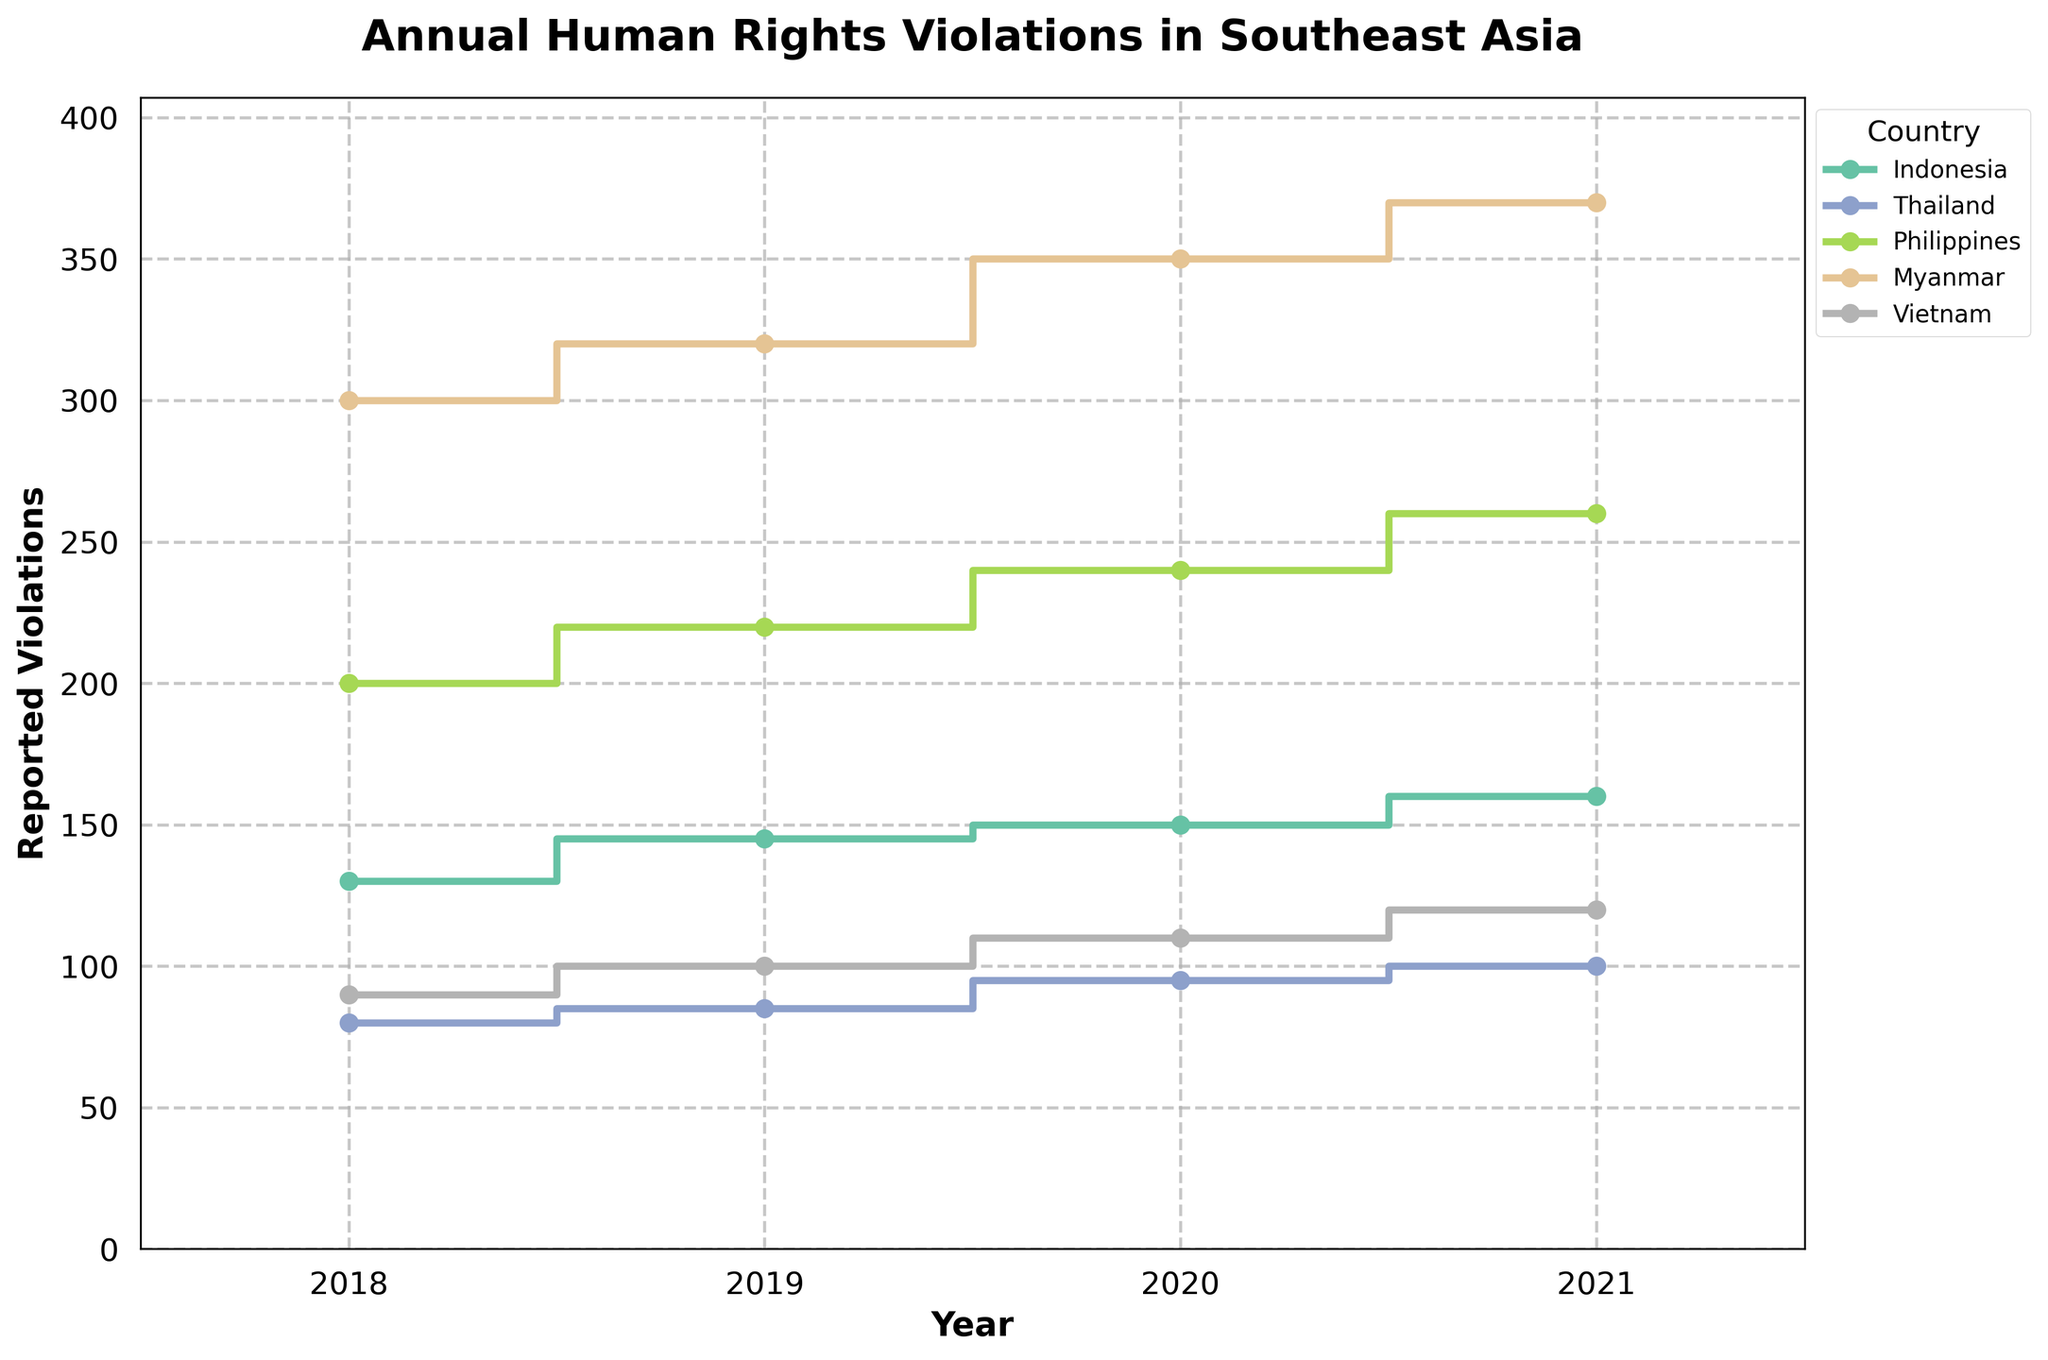What is the title of the figure? The title of the figure is typically found at the top of the chart. It describes the main topic or purpose of the figure, which in this case is "Annual Human Rights Violations in Southeast Asia".
Answer: Annual Human Rights Violations in Southeast Asia Which country had the highest number of reported violations in 2018? Looking at the step plot for the year 2018, observe which country's data point is the highest. Myanmar's data point is the highest in 2018.
Answer: Myanmar In which years did Indonesia report an increase in human rights violations? By observing the trend line for Indonesia, notice that the reported violations increased every year. Hence, the increases occurred in 2019, 2020, and 2021.
Answer: 2019, 2020, 2021 What is the difference in the number of reported violations between the Philippines and Vietnam in 2020? First, find the reported violations for both countries in 2020 from the step plot. The Philippines had 240, and Vietnam had 110. The difference is calculated as 240 - 110.
Answer: 130 How did the trend of reported violations change in Thailand from 2018 to 2021? Observing Thailand's line, it shows a consistent increase each year from 80 in 2018 to 100 in 2021. Thus, the trend is gradually increasing.
Answer: Gradually increasing Which country showed the smallest increase in reported violations from 2018 to 2021? To find this, calculate the increase for each country by subtracting reported violations in 2018 from those in 2021. The smallest increase is in Thailand: 100 - 80 = 20.
Answer: Thailand Compare the number of reported violations in Indonesia and Myanmar in 2021. Which country reported more? Look at the data points for Indonesia and Myanmar in 2021. Indonesia reported 160, and Myanmar reported 370. Myanmar reported more.
Answer: Myanmar What is the average number of reported violations for the Philippines from 2018 to 2021? Add the reported violations for the Philippines each year (200 + 220 + 240 + 260) and then divide by the number of years (4). This gives us (920 / 4).
Answer: 230 Which country had the most consistent increase in reported violations each year? By examining the slopes of the step plots for all countries, all countries show increases but the increments for the Philippines (200, 220, 240, 260) are steady.
Answer: Philippines 점 From the data, suppose a new country (e.g., Malaysia) is added. What would be the approximate reporting trend if it shows a 5% yearly increase starting from 100 violations in 2018? Starting with a base of 100 in 2018, a 5% increase per year would yield (100 * 1.05 = 105 in 2019, 105 * 1.05 ≈ 110.25 in 2020, 110.25 * 1.05 ≈ 115.76 in 2021).
Answer: 105 in 2019, ≈ 110.25 in 2020, ≈ 115.76 in 2021 